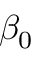<formula> <loc_0><loc_0><loc_500><loc_500>\beta _ { 0 }</formula> 